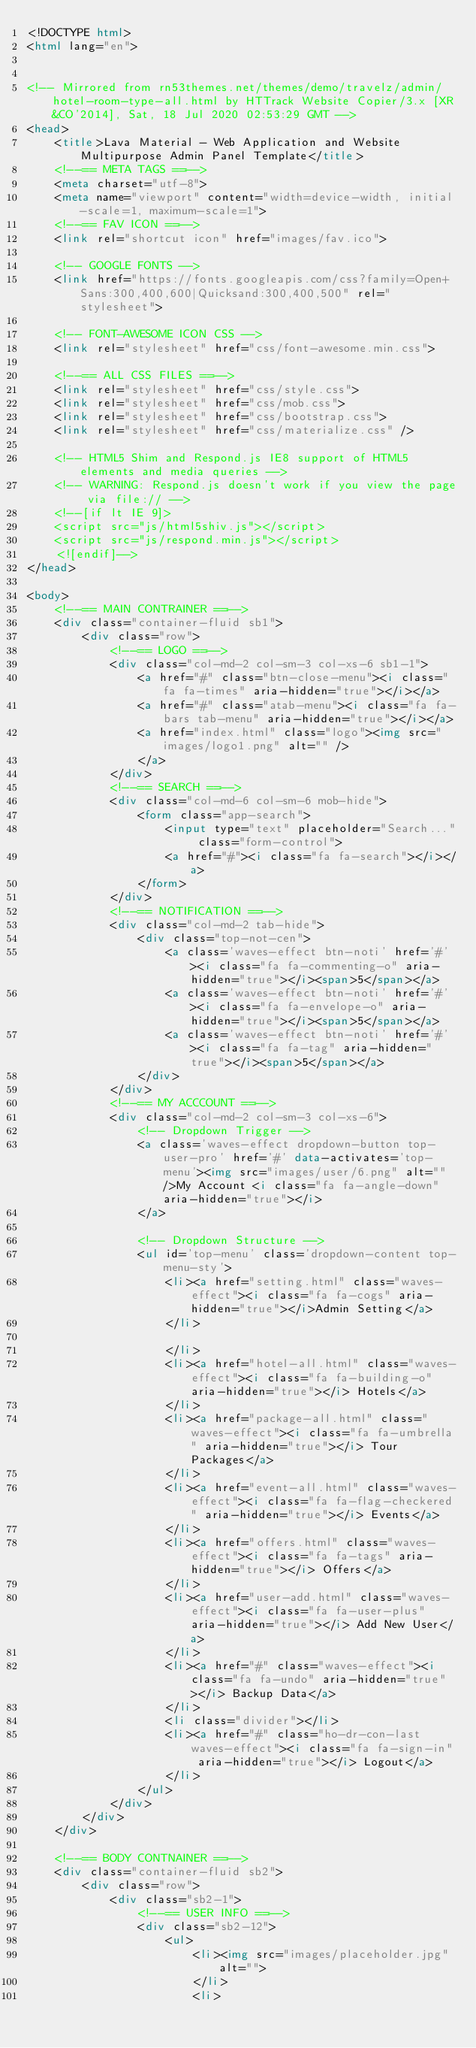Convert code to text. <code><loc_0><loc_0><loc_500><loc_500><_HTML_><!DOCTYPE html>
<html lang="en">


<!-- Mirrored from rn53themes.net/themes/demo/travelz/admin/hotel-room-type-all.html by HTTrack Website Copier/3.x [XR&CO'2014], Sat, 18 Jul 2020 02:53:29 GMT -->
<head>
    <title>Lava Material - Web Application and Website Multipurpose Admin Panel Template</title>
    <!--== META TAGS ==-->
    <meta charset="utf-8">
    <meta name="viewport" content="width=device-width, initial-scale=1, maximum-scale=1">
    <!--== FAV ICON ==-->
    <link rel="shortcut icon" href="images/fav.ico">

    <!-- GOOGLE FONTS -->
    <link href="https://fonts.googleapis.com/css?family=Open+Sans:300,400,600|Quicksand:300,400,500" rel="stylesheet">

    <!-- FONT-AWESOME ICON CSS -->
    <link rel="stylesheet" href="css/font-awesome.min.css">

    <!--== ALL CSS FILES ==-->
    <link rel="stylesheet" href="css/style.css">
    <link rel="stylesheet" href="css/mob.css">
    <link rel="stylesheet" href="css/bootstrap.css">
    <link rel="stylesheet" href="css/materialize.css" />

    <!-- HTML5 Shim and Respond.js IE8 support of HTML5 elements and media queries -->
    <!-- WARNING: Respond.js doesn't work if you view the page via file:// -->
    <!--[if lt IE 9]>
	<script src="js/html5shiv.js"></script>
	<script src="js/respond.min.js"></script>
	<![endif]-->
</head>

<body>
    <!--== MAIN CONTRAINER ==-->
    <div class="container-fluid sb1">
        <div class="row">
            <!--== LOGO ==-->
            <div class="col-md-2 col-sm-3 col-xs-6 sb1-1">
                <a href="#" class="btn-close-menu"><i class="fa fa-times" aria-hidden="true"></i></a>
                <a href="#" class="atab-menu"><i class="fa fa-bars tab-menu" aria-hidden="true"></i></a>
                <a href="index.html" class="logo"><img src="images/logo1.png" alt="" />
                </a>
            </div>
            <!--== SEARCH ==-->
            <div class="col-md-6 col-sm-6 mob-hide">
                <form class="app-search">
                    <input type="text" placeholder="Search..." class="form-control">
                    <a href="#"><i class="fa fa-search"></i></a>
                </form>
            </div>
            <!--== NOTIFICATION ==-->
            <div class="col-md-2 tab-hide">
                <div class="top-not-cen">
                    <a class='waves-effect btn-noti' href='#'><i class="fa fa-commenting-o" aria-hidden="true"></i><span>5</span></a>
                    <a class='waves-effect btn-noti' href='#'><i class="fa fa-envelope-o" aria-hidden="true"></i><span>5</span></a>
                    <a class='waves-effect btn-noti' href='#'><i class="fa fa-tag" aria-hidden="true"></i><span>5</span></a>
                </div>
            </div>
            <!--== MY ACCCOUNT ==-->
            <div class="col-md-2 col-sm-3 col-xs-6">
                <!-- Dropdown Trigger -->
                <a class='waves-effect dropdown-button top-user-pro' href='#' data-activates='top-menu'><img src="images/user/6.png" alt="" />My Account <i class="fa fa-angle-down" aria-hidden="true"></i>
                </a>

                <!-- Dropdown Structure -->
                <ul id='top-menu' class='dropdown-content top-menu-sty'>
                    <li><a href="setting.html" class="waves-effect"><i class="fa fa-cogs" aria-hidden="true"></i>Admin Setting</a>
                    </li>
                    
                    </li>
                    <li><a href="hotel-all.html" class="waves-effect"><i class="fa fa-building-o" aria-hidden="true"></i> Hotels</a>
                    </li>
                    <li><a href="package-all.html" class="waves-effect"><i class="fa fa-umbrella" aria-hidden="true"></i> Tour Packages</a>
                    </li>
                    <li><a href="event-all.html" class="waves-effect"><i class="fa fa-flag-checkered" aria-hidden="true"></i> Events</a>
                    </li>
                    <li><a href="offers.html" class="waves-effect"><i class="fa fa-tags" aria-hidden="true"></i> Offers</a>
                    </li>
                    <li><a href="user-add.html" class="waves-effect"><i class="fa fa-user-plus" aria-hidden="true"></i> Add New User</a>
                    </li>
                    <li><a href="#" class="waves-effect"><i class="fa fa-undo" aria-hidden="true"></i> Backup Data</a>
                    </li>
                    <li class="divider"></li>
                    <li><a href="#" class="ho-dr-con-last waves-effect"><i class="fa fa-sign-in" aria-hidden="true"></i> Logout</a>
                    </li>
                </ul>
            </div>
        </div>
    </div>

    <!--== BODY CONTNAINER ==-->
    <div class="container-fluid sb2">
        <div class="row">
            <div class="sb2-1">
                <!--== USER INFO ==-->
                <div class="sb2-12">
                    <ul>
                        <li><img src="images/placeholder.jpg" alt="">
                        </li>
                        <li></code> 